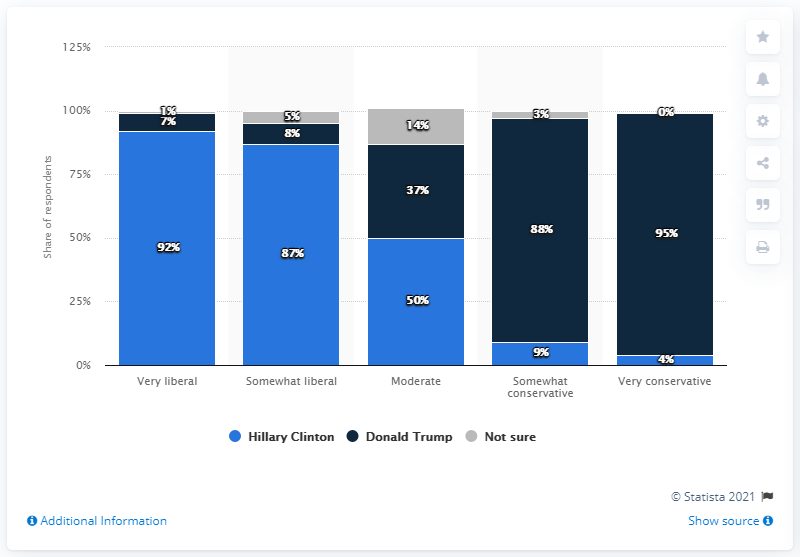Identify some key points in this picture. Donald Trump was the most popular candidate for President of the United States in February 2017. 